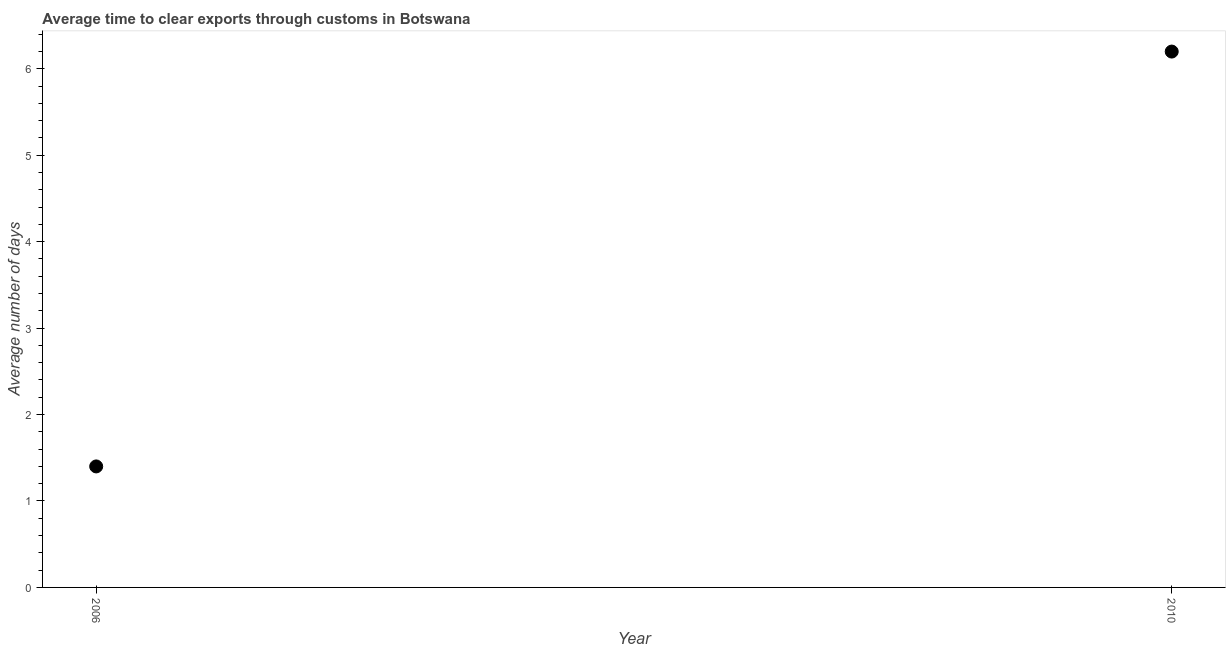Across all years, what is the minimum time to clear exports through customs?
Your answer should be compact. 1.4. What is the difference between the time to clear exports through customs in 2006 and 2010?
Provide a succinct answer. -4.8. What is the ratio of the time to clear exports through customs in 2006 to that in 2010?
Your answer should be compact. 0.23. In how many years, is the time to clear exports through customs greater than the average time to clear exports through customs taken over all years?
Your answer should be very brief. 1. What is the difference between two consecutive major ticks on the Y-axis?
Give a very brief answer. 1. Does the graph contain any zero values?
Keep it short and to the point. No. What is the title of the graph?
Offer a terse response. Average time to clear exports through customs in Botswana. What is the label or title of the X-axis?
Provide a short and direct response. Year. What is the label or title of the Y-axis?
Offer a terse response. Average number of days. What is the Average number of days in 2006?
Your response must be concise. 1.4. What is the difference between the Average number of days in 2006 and 2010?
Keep it short and to the point. -4.8. What is the ratio of the Average number of days in 2006 to that in 2010?
Your answer should be very brief. 0.23. 